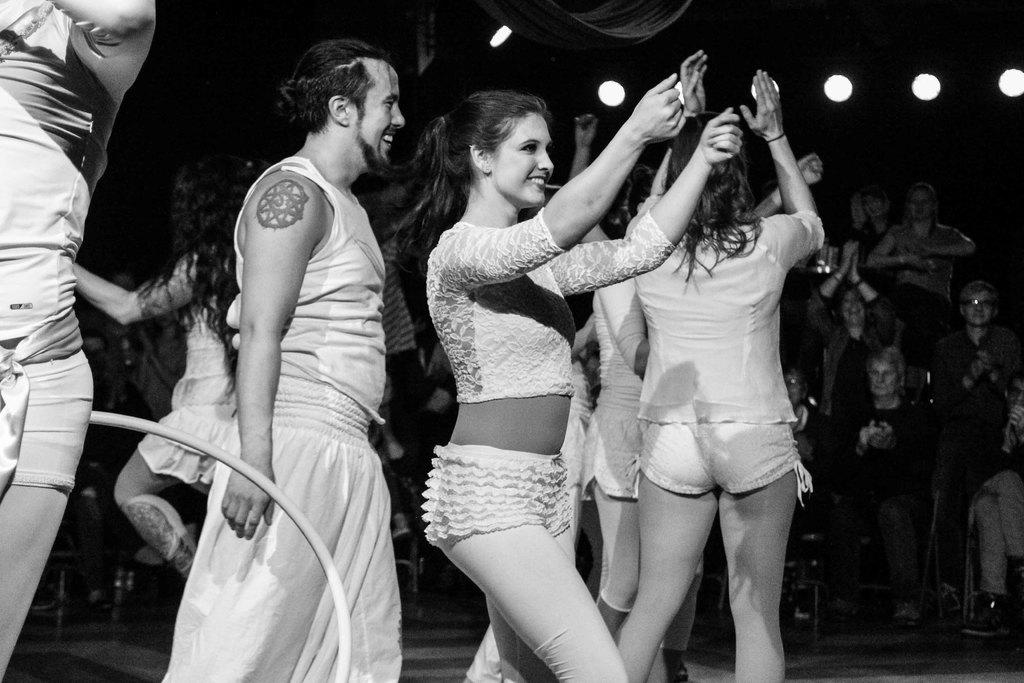What is happening in the image involving the people? There are people in motion in the image. What can be seen in the image besides the people? There is an object in the image. Can you describe the background of the image? There are people visible in the background of the image, and there are lights in the background as well. How would you describe the lighting conditions in the image? The environment in the image is dark. What type of quince is being used as a prop in the image? There is no quince present in the image. Can you tell me how many guns are visible in the image? There are no guns visible in the image. 